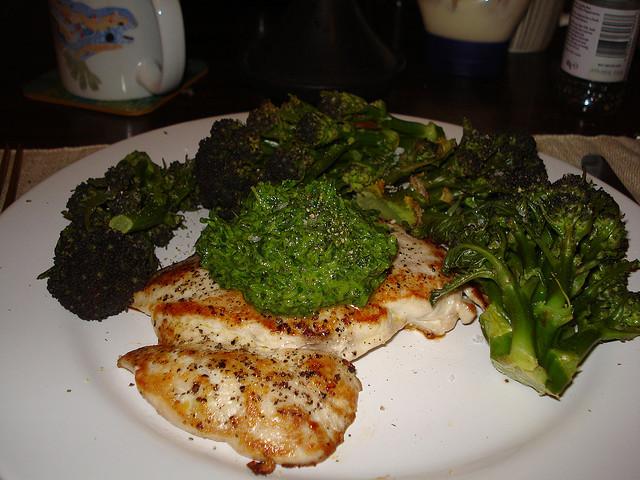How many meats are on the plate?
Answer briefly. 2. What kind of food is this?
Write a very short answer. Chicken and broccoli. What color is the main dish?
Quick response, please. White. Is this food hot or cold?
Be succinct. Hot. Does the broccoli look fresh?
Short answer required. Yes. Do you see pasta?
Keep it brief. No. Is this a healthy meal?
Be succinct. Yes. What kind of plate is this?
Answer briefly. White. Is there any meat here?
Answer briefly. Yes. What kind of potato are they having with their meal?
Quick response, please. None. Is there any bread in the picture?
Answer briefly. No. Are there any chopsticks on the plate?
Concise answer only. No. Do the greens appear fresh?
Concise answer only. Yes. What is the broccoli covered in?
Give a very brief answer. Oil. What type of greens are on the plate?
Keep it brief. Broccoli. How many different vegetables are on the plate?
Quick response, please. 1. How many plates are there?
Answer briefly. 1. Is the plate full?
Short answer required. Yes. Are there any vegetables on the plate?
Write a very short answer. Yes. What kind of meat is on the table?
Write a very short answer. Chicken. What color is dominant?
Write a very short answer. Green. Where does the protein live before it's caught?
Answer briefly. Farm. What kind of vegetable is this?
Keep it brief. Broccoli. Is there something here one might chew on to freshen the breathe after the meal?
Write a very short answer. No. What type of meat is on the plate?
Answer briefly. Chicken. What is the chicken and broccoli on top of?
Give a very brief answer. Plate. Is the plate round?
Short answer required. Yes. What kind of sauce is on this meat?
Quick response, please. Lemon pepper. How many tacos are on the plate?
Be succinct. 0. Is the food fatty?
Answer briefly. No. Is there a coffee cup?
Write a very short answer. Yes. What kind of restaurant is this?
Write a very short answer. American. What kind of meat is in this picture?
Concise answer only. Chicken. Do you see any fruit?
Concise answer only. No. What is the green vegetable?
Short answer required. Broccoli. Where would the green fruit grow?
Quick response, please. Ground. Are the portions bite sized?
Quick response, please. No. How many pickles are there?
Be succinct. 0. Is the food already cut?
Be succinct. No. Is this meal healthy?
Give a very brief answer. Yes. What are these creations made of?
Keep it brief. Chicken and broccoli. 